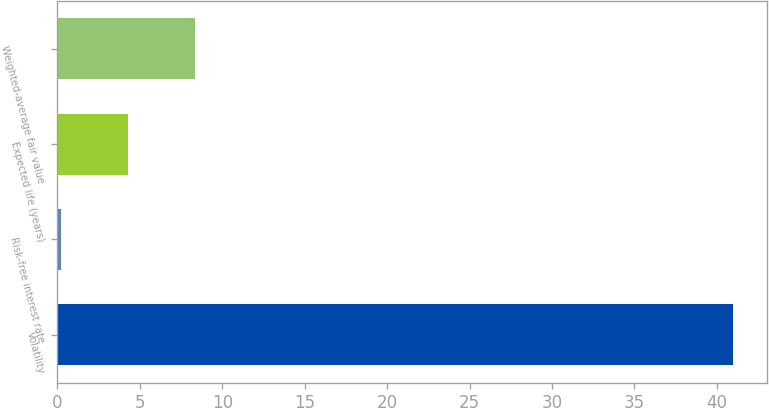Convert chart. <chart><loc_0><loc_0><loc_500><loc_500><bar_chart><fcel>Volatility<fcel>Risk-free interest rate<fcel>Expected life (years)<fcel>Weighted-average fair value<nl><fcel>41<fcel>0.2<fcel>4.28<fcel>8.36<nl></chart> 